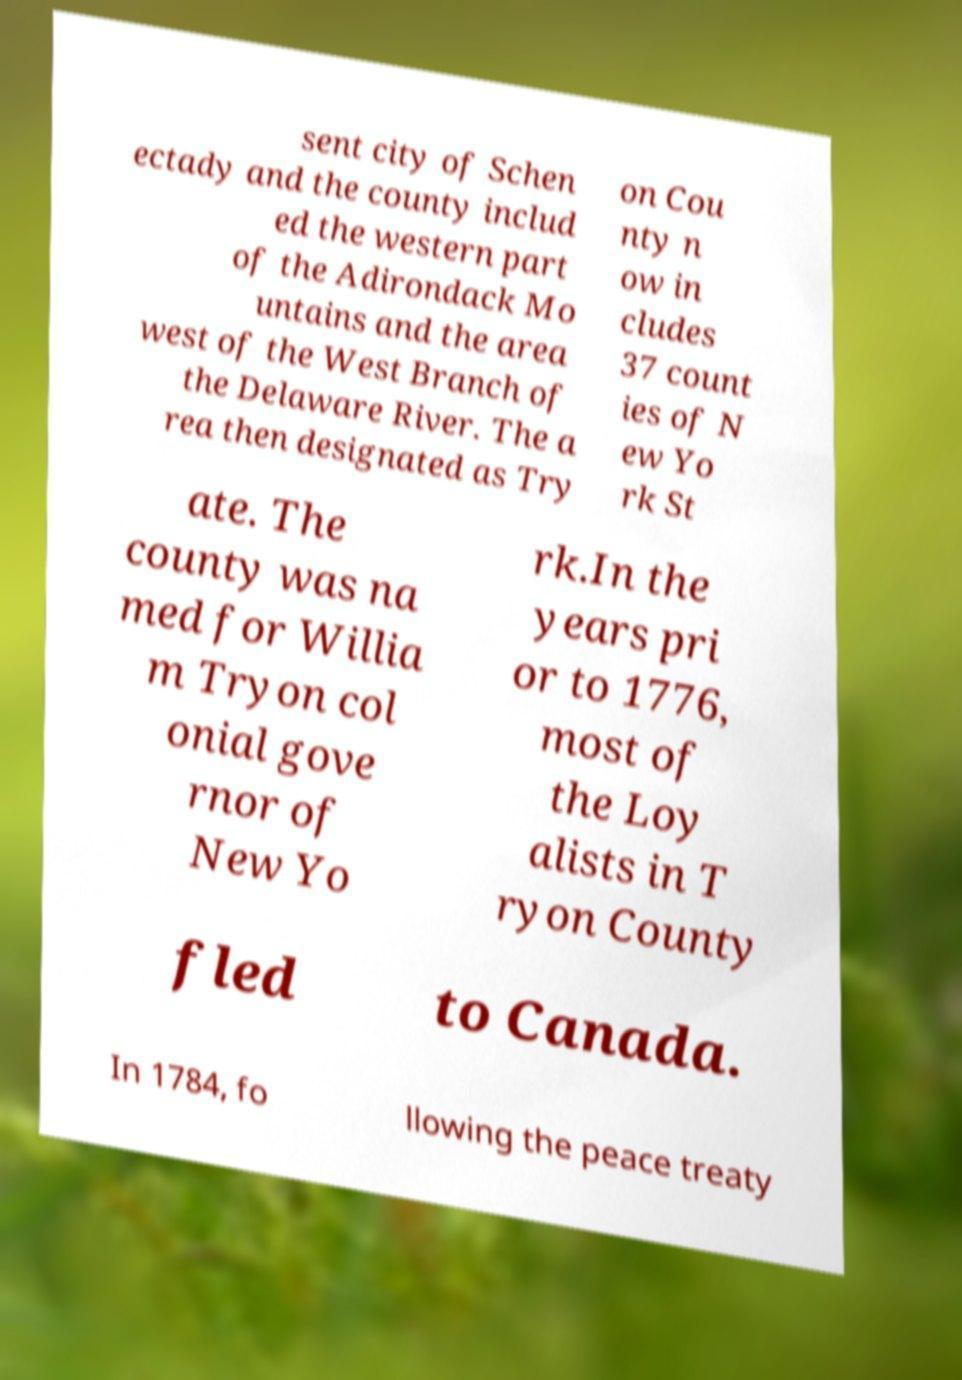What messages or text are displayed in this image? I need them in a readable, typed format. sent city of Schen ectady and the county includ ed the western part of the Adirondack Mo untains and the area west of the West Branch of the Delaware River. The a rea then designated as Try on Cou nty n ow in cludes 37 count ies of N ew Yo rk St ate. The county was na med for Willia m Tryon col onial gove rnor of New Yo rk.In the years pri or to 1776, most of the Loy alists in T ryon County fled to Canada. In 1784, fo llowing the peace treaty 